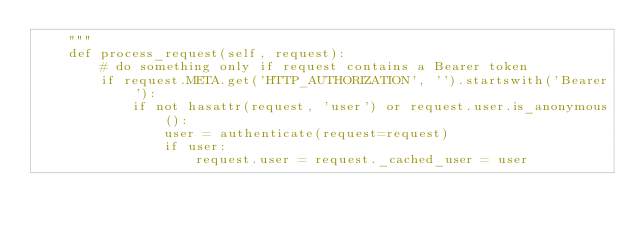Convert code to text. <code><loc_0><loc_0><loc_500><loc_500><_Python_>    """
    def process_request(self, request):
        # do something only if request contains a Bearer token
        if request.META.get('HTTP_AUTHORIZATION', '').startswith('Bearer'):
            if not hasattr(request, 'user') or request.user.is_anonymous():
                user = authenticate(request=request)
                if user:
                    request.user = request._cached_user = user
</code> 